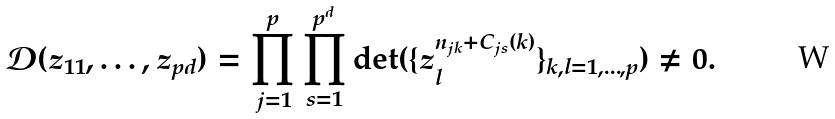Convert formula to latex. <formula><loc_0><loc_0><loc_500><loc_500>\mathcal { D } ( z _ { 1 1 } , \dots , z _ { p d } ) = \prod _ { j = 1 } ^ { p } \prod _ { s = 1 } ^ { p ^ { d } } \det ( \{ z _ { l } ^ { n _ { j k } + C _ { j s } ( k ) } \} _ { k , l = 1 , \dots , p } ) \neq 0 .</formula> 